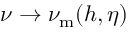Convert formula to latex. <formula><loc_0><loc_0><loc_500><loc_500>\nu \rightarrow \nu _ { m } ( h , \eta )</formula> 